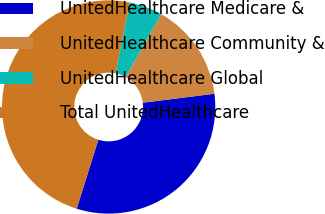Convert chart. <chart><loc_0><loc_0><loc_500><loc_500><pie_chart><fcel>UnitedHealthcare Medicare &<fcel>UnitedHealthcare Community &<fcel>UnitedHealthcare Global<fcel>Total UnitedHealthcare<nl><fcel>31.83%<fcel>14.81%<fcel>5.04%<fcel>48.32%<nl></chart> 